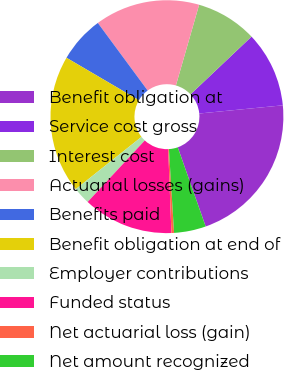<chart> <loc_0><loc_0><loc_500><loc_500><pie_chart><fcel>Benefit obligation at<fcel>Service cost gross<fcel>Interest cost<fcel>Actuarial losses (gains)<fcel>Benefits paid<fcel>Benefit obligation at end of<fcel>Employer contributions<fcel>Funded status<fcel>Net actuarial loss (gain)<fcel>Net amount recognized<nl><fcel>21.16%<fcel>10.51%<fcel>8.48%<fcel>14.57%<fcel>6.45%<fcel>19.13%<fcel>2.39%<fcel>12.54%<fcel>0.36%<fcel>4.42%<nl></chart> 